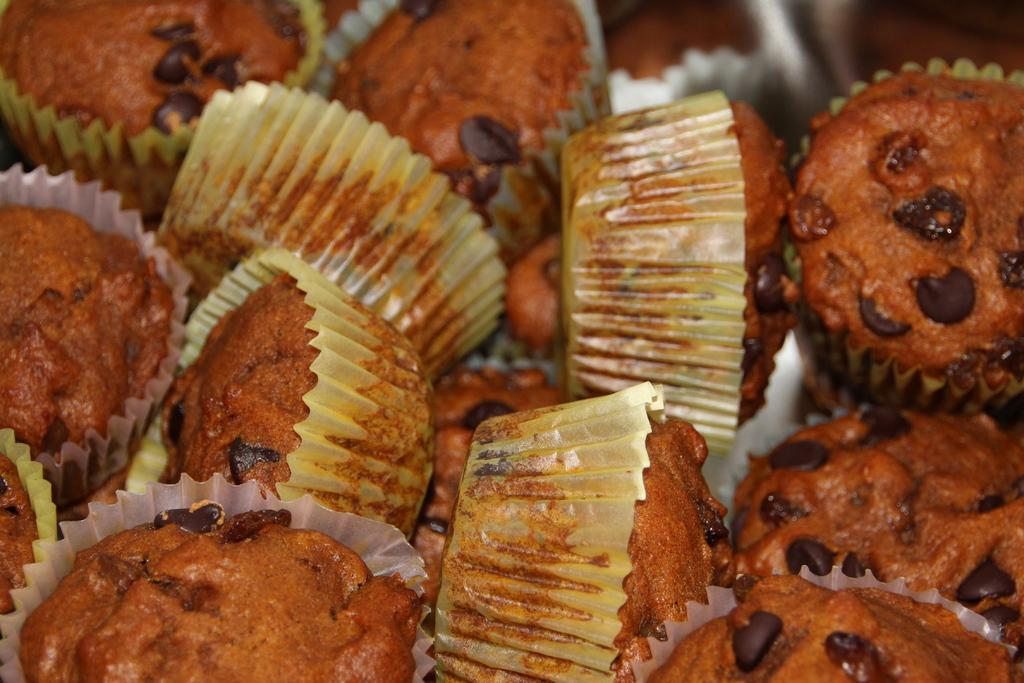What type of food is visible in the image? There is a group of cupcakes in the image. Can you describe the arrangement of the cupcakes? The provided facts do not mention the arrangement of the cupcakes. What might be used to serve or eat the cupcakes? The provided facts do not mention any utensils or serving dishes. What type of ear is visible on the cupcakes in the image? There are no ears visible on the cupcakes in the image. How many cats are sitting on top of the cupcakes in the image? There are no cats present in the image. 